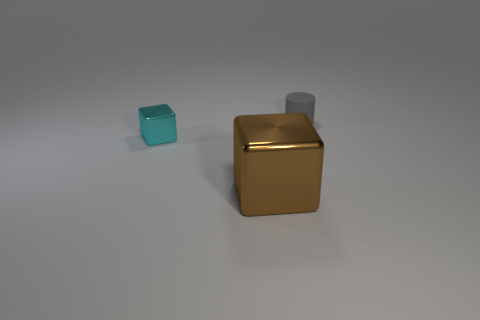Does the gray thing have the same material as the large brown object?
Your answer should be compact. No. What number of other objects are there of the same shape as the tiny gray rubber object?
Your answer should be very brief. 0. There is a object that is both behind the brown object and to the right of the small cyan metal block; what is its size?
Provide a succinct answer. Small. What number of metal things are either large blue cubes or tiny cyan cubes?
Offer a terse response. 1. There is a tiny thing that is in front of the gray cylinder; is its shape the same as the metal object that is in front of the cyan shiny cube?
Provide a short and direct response. Yes. Is there a large cube that has the same material as the cyan thing?
Provide a short and direct response. Yes. What is the color of the large metal thing?
Your response must be concise. Brown. What is the size of the thing right of the large brown object?
Offer a terse response. Small. How many small cylinders are the same color as the large cube?
Provide a succinct answer. 0. Is there a small object behind the small thing that is left of the small cylinder?
Your answer should be compact. Yes. 